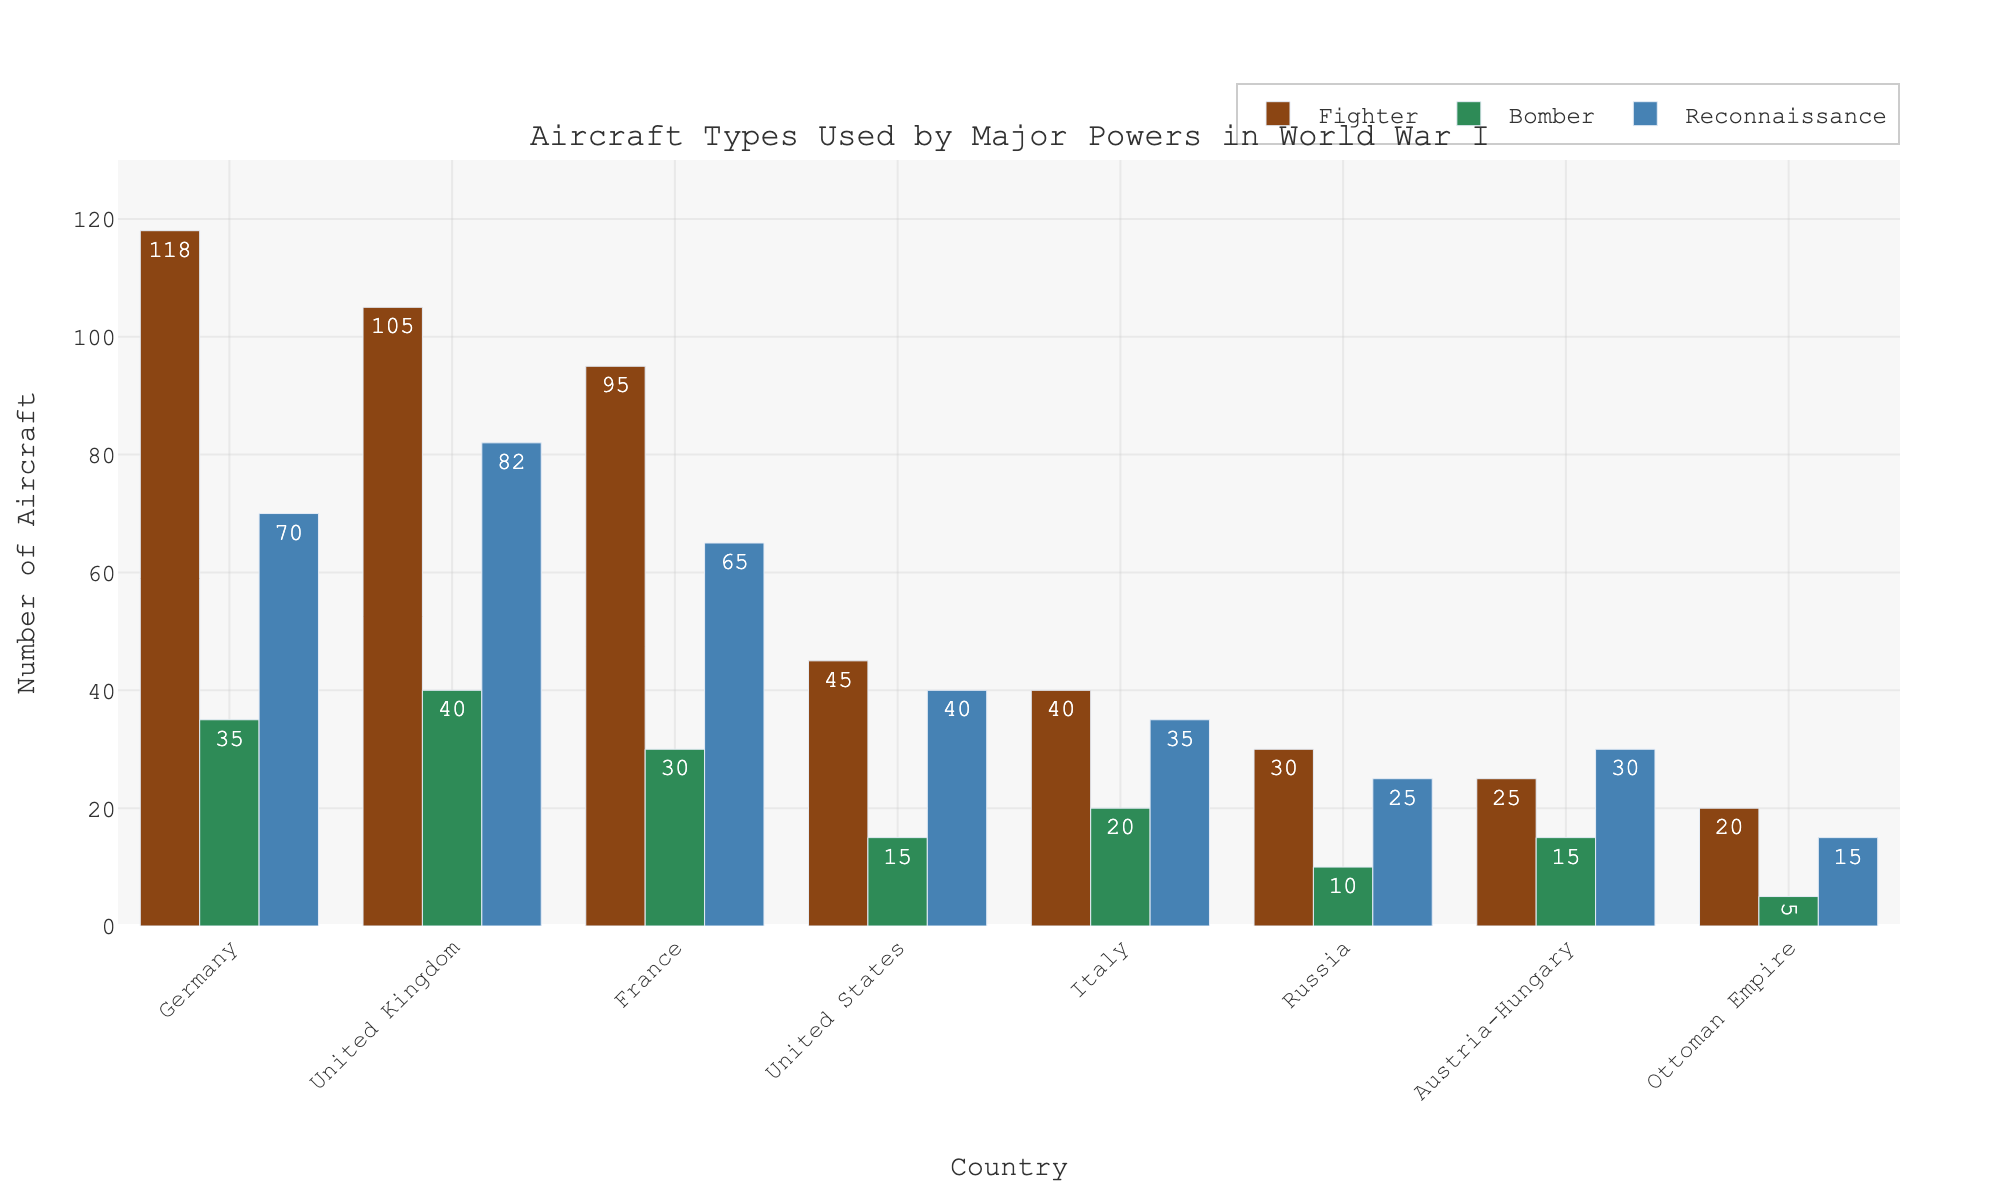Which country has the highest number of fighter aircraft? The bar representing Germany's fighters is the tallest among all fighter bars.
Answer: Germany What is the total number of reconnaissance planes used by the Allied Powers (United Kingdom, France, United States, and Italy)? Add the reconnaissance plane counts for the United Kingdom (82), France (65), United States (40), and Italy (35): 82 + 65 + 40 + 35 = 222.
Answer: 222 Which aircraft type does the United States have the fewest of, and how many are there? The height of the United States bars shows that the bomber bar is the shortest at 15.
Answer: Bombers, 15 Is the number of fighter aircraft in France greater than the number of reconnaissance aircraft in Italy? France's fighter bar height is 95, and Italy's reconnaissance bar height is 35. Since 95 > 35, the answer is yes.
Answer: Yes What is the difference between the number of bombers used by Germany and Austria-Hungary? Subtract the number of Austria-Hungary's bombers (15) from Germany's bombers (35): 35 - 15 = 20.
Answer: 20 Which country has more reconnaissance planes, Russia or the Ottoman Empire, and by how many? Russia has 25 reconnaissance planes, and the Ottoman Empire has 15. The difference is 25 - 15 = 10.
Answer: Russia, 10 What is the average number of fighter aircraft for the Central Powers (Germany, Austria-Hungary, and Ottoman Empire)? Add the fighter planes of Germany (118), Austria-Hungary (25), and Ottoman Empire (20), then divide by 3: (118 + 25 + 20) / 3 ≈ 54.33.
Answer: 54.33 Which country has the smallest total number of aircraft across all types and what is that total? Sum the aircraft for the Ottoman Empire across all types: 20 (fighters) + 5 (bombers) + 15 (reconnaissance) = 40.
Answer: Ottoman Empire, 40 